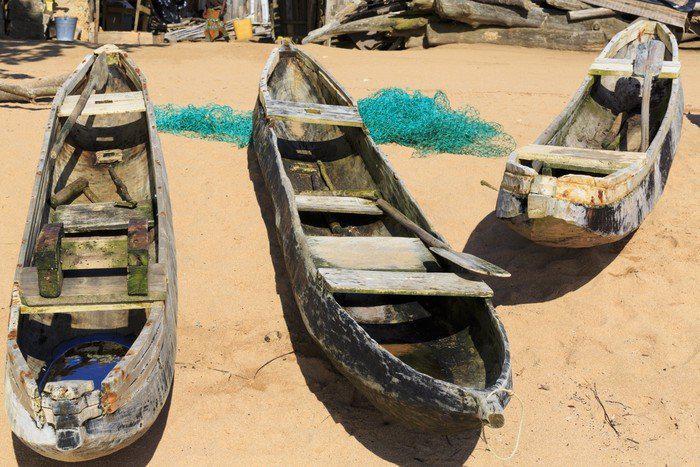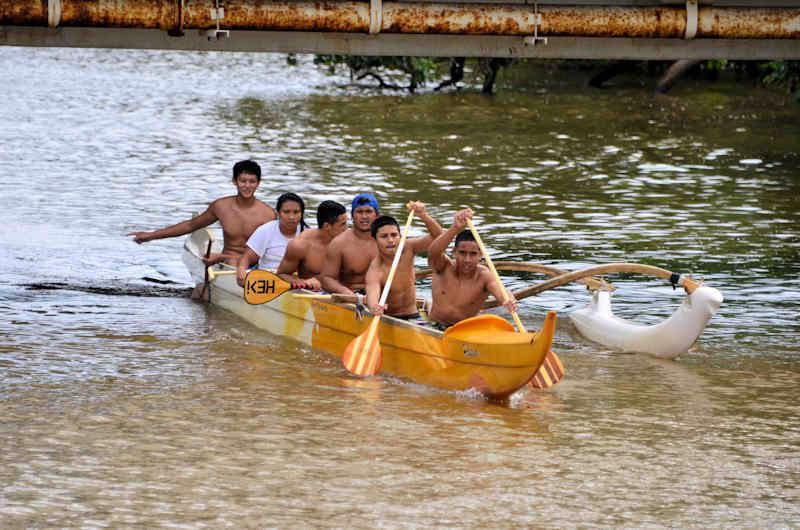The first image is the image on the left, the second image is the image on the right. Assess this claim about the two images: "In one image there are six or more men in a boat being paddled through water.". Correct or not? Answer yes or no. Yes. 